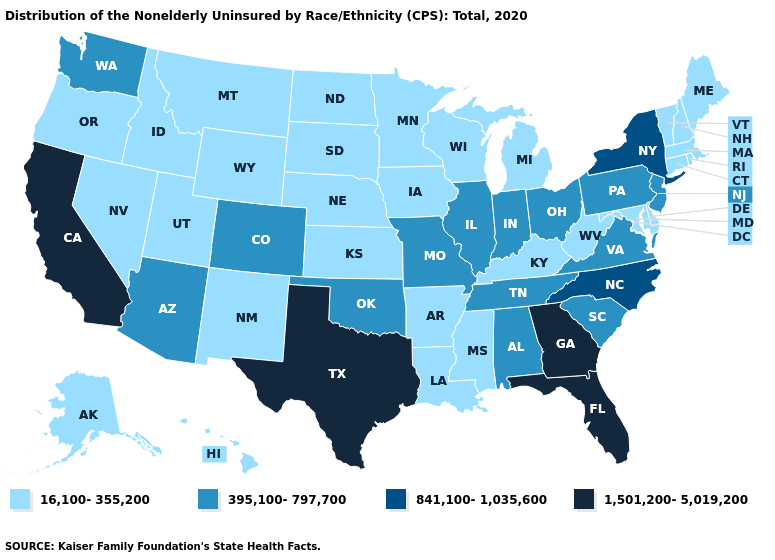Does Utah have a higher value than Arkansas?
Short answer required. No. Which states hav the highest value in the South?
Give a very brief answer. Florida, Georgia, Texas. What is the highest value in states that border Connecticut?
Answer briefly. 841,100-1,035,600. Name the states that have a value in the range 841,100-1,035,600?
Answer briefly. New York, North Carolina. What is the value of California?
Keep it brief. 1,501,200-5,019,200. Which states have the lowest value in the USA?
Quick response, please. Alaska, Arkansas, Connecticut, Delaware, Hawaii, Idaho, Iowa, Kansas, Kentucky, Louisiana, Maine, Maryland, Massachusetts, Michigan, Minnesota, Mississippi, Montana, Nebraska, Nevada, New Hampshire, New Mexico, North Dakota, Oregon, Rhode Island, South Dakota, Utah, Vermont, West Virginia, Wisconsin, Wyoming. Among the states that border Louisiana , which have the lowest value?
Give a very brief answer. Arkansas, Mississippi. Is the legend a continuous bar?
Quick response, please. No. What is the value of Idaho?
Answer briefly. 16,100-355,200. Among the states that border North Carolina , which have the highest value?
Write a very short answer. Georgia. Which states hav the highest value in the Northeast?
Write a very short answer. New York. Which states have the lowest value in the West?
Give a very brief answer. Alaska, Hawaii, Idaho, Montana, Nevada, New Mexico, Oregon, Utah, Wyoming. What is the value of Illinois?
Concise answer only. 395,100-797,700. What is the value of Utah?
Concise answer only. 16,100-355,200. 